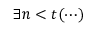<formula> <loc_0><loc_0><loc_500><loc_500>\exists n < t ( \cdots )</formula> 